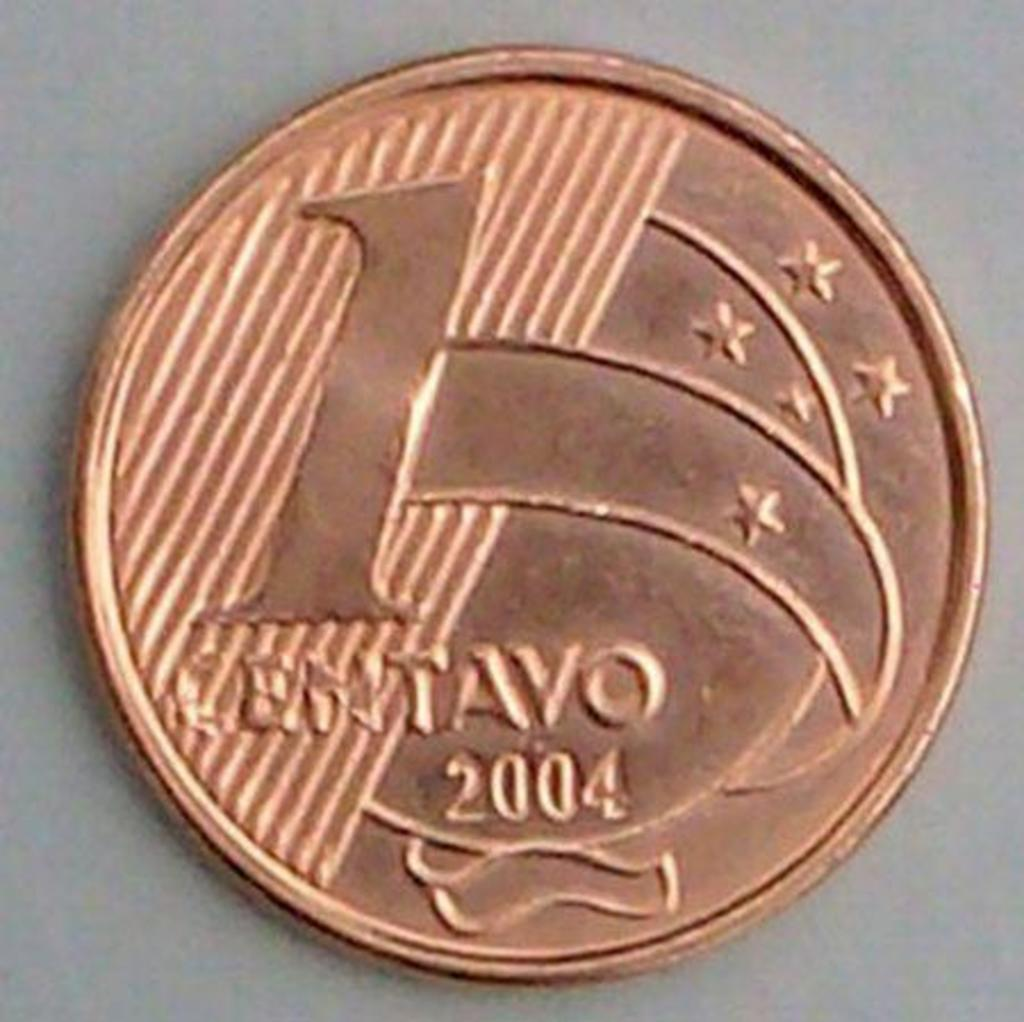<image>
Offer a succinct explanation of the picture presented. a bronze coin for 1 centavo minted in 2004 